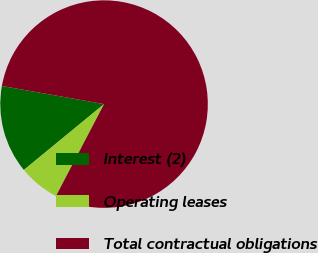Convert chart. <chart><loc_0><loc_0><loc_500><loc_500><pie_chart><fcel>Interest (2)<fcel>Operating leases<fcel>Total contractual obligations<nl><fcel>13.74%<fcel>6.39%<fcel>79.88%<nl></chart> 